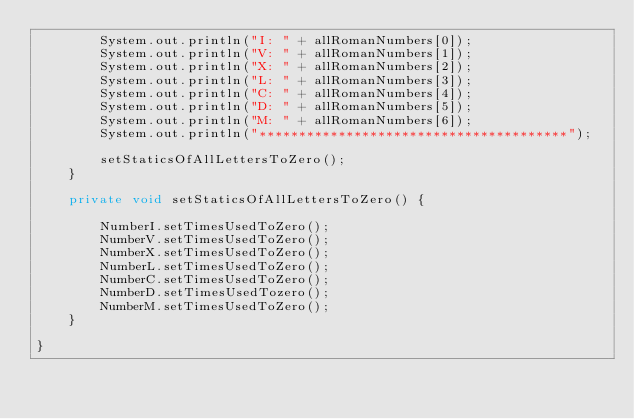<code> <loc_0><loc_0><loc_500><loc_500><_Java_>		System.out.println("I: " + allRomanNumbers[0]);
		System.out.println("V: " + allRomanNumbers[1]);
		System.out.println("X: " + allRomanNumbers[2]);
		System.out.println("L: " + allRomanNumbers[3]);
		System.out.println("C: " + allRomanNumbers[4]);
		System.out.println("D: " + allRomanNumbers[5]);
		System.out.println("M: " + allRomanNumbers[6]);
		System.out.println("***************************************");
		
		setStaticsOfAllLettersToZero();
	}
	
	private void setStaticsOfAllLettersToZero() {
		
		NumberI.setTimesUsedToZero();
		NumberV.setTimesUsedToZero();
		NumberX.setTimesUsedToZero();
		NumberL.setTimesUsedToZero();
		NumberC.setTimesUsedToZero();
		NumberD.setTimesUsedTozero();
		NumberM.setTimesUsedToZero();
	}
	
}
</code> 